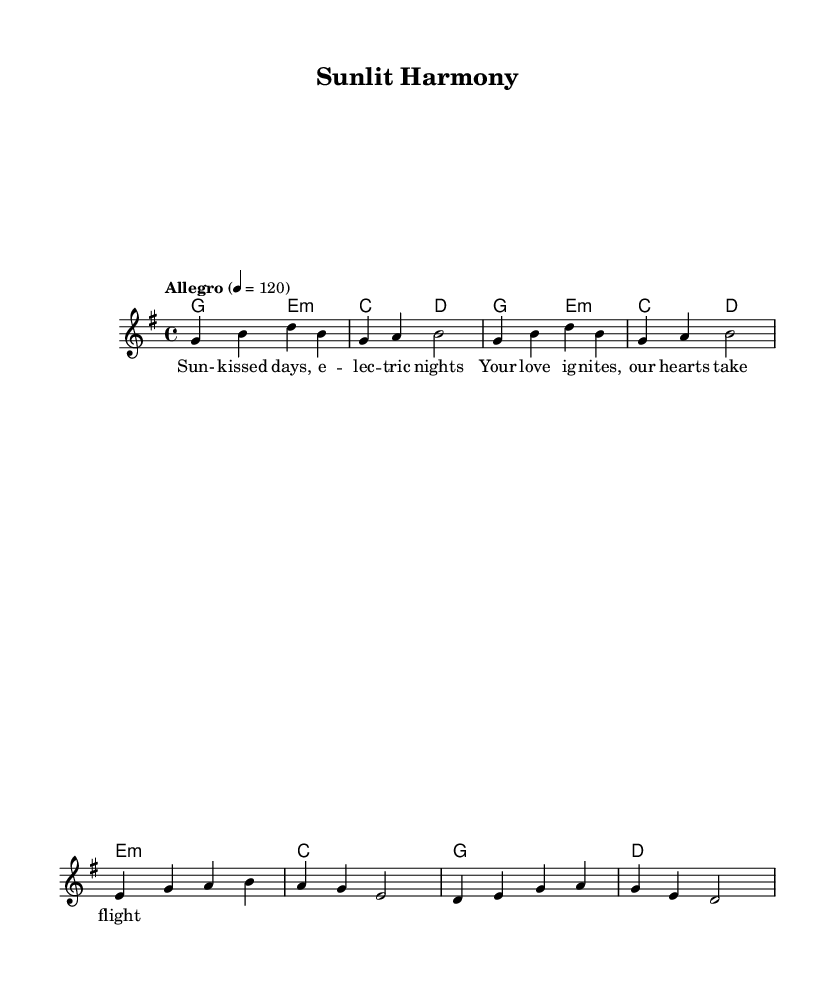What is the key signature of this music? The key signature shows one sharp (F#), indicating that the music is in G major, which has one sharp.
Answer: G major What is the time signature of this piece? The time signature is indicated at the beginning of the score as 4/4, meaning there are four beats in a measure and the quarter note gets one beat.
Answer: 4/4 What is the tempo marking for this piece? The tempo marking is written as "Allegro" with a metronome marking of 120, indicating a fast pace for the piece.
Answer: Allegro 4 = 120 What is the main theme of the lyrics? The lyrics describe sunny days and a sense of love that elevates emotions, focusing on joy and romance.
Answer: Love and joy How many measures are in the chorus section? The chorus section contains four measures, as indicated by the grouping of four bars in the sheet music.
Answer: Four measures What chord follows the second line of lyrics? The chord that follows the second line of lyrics ("takes flight") is D major, which can be found in the harmonies below the melody.
Answer: D major What musical elements contribute to the "summery, feel-good" vibe of this duet? The use of G major, upbeat tempo, catchy electronic hooks, and lyrics about love and sunny days create a summery, feel-good atmosphere.
Answer: G major and upbeat tempo 